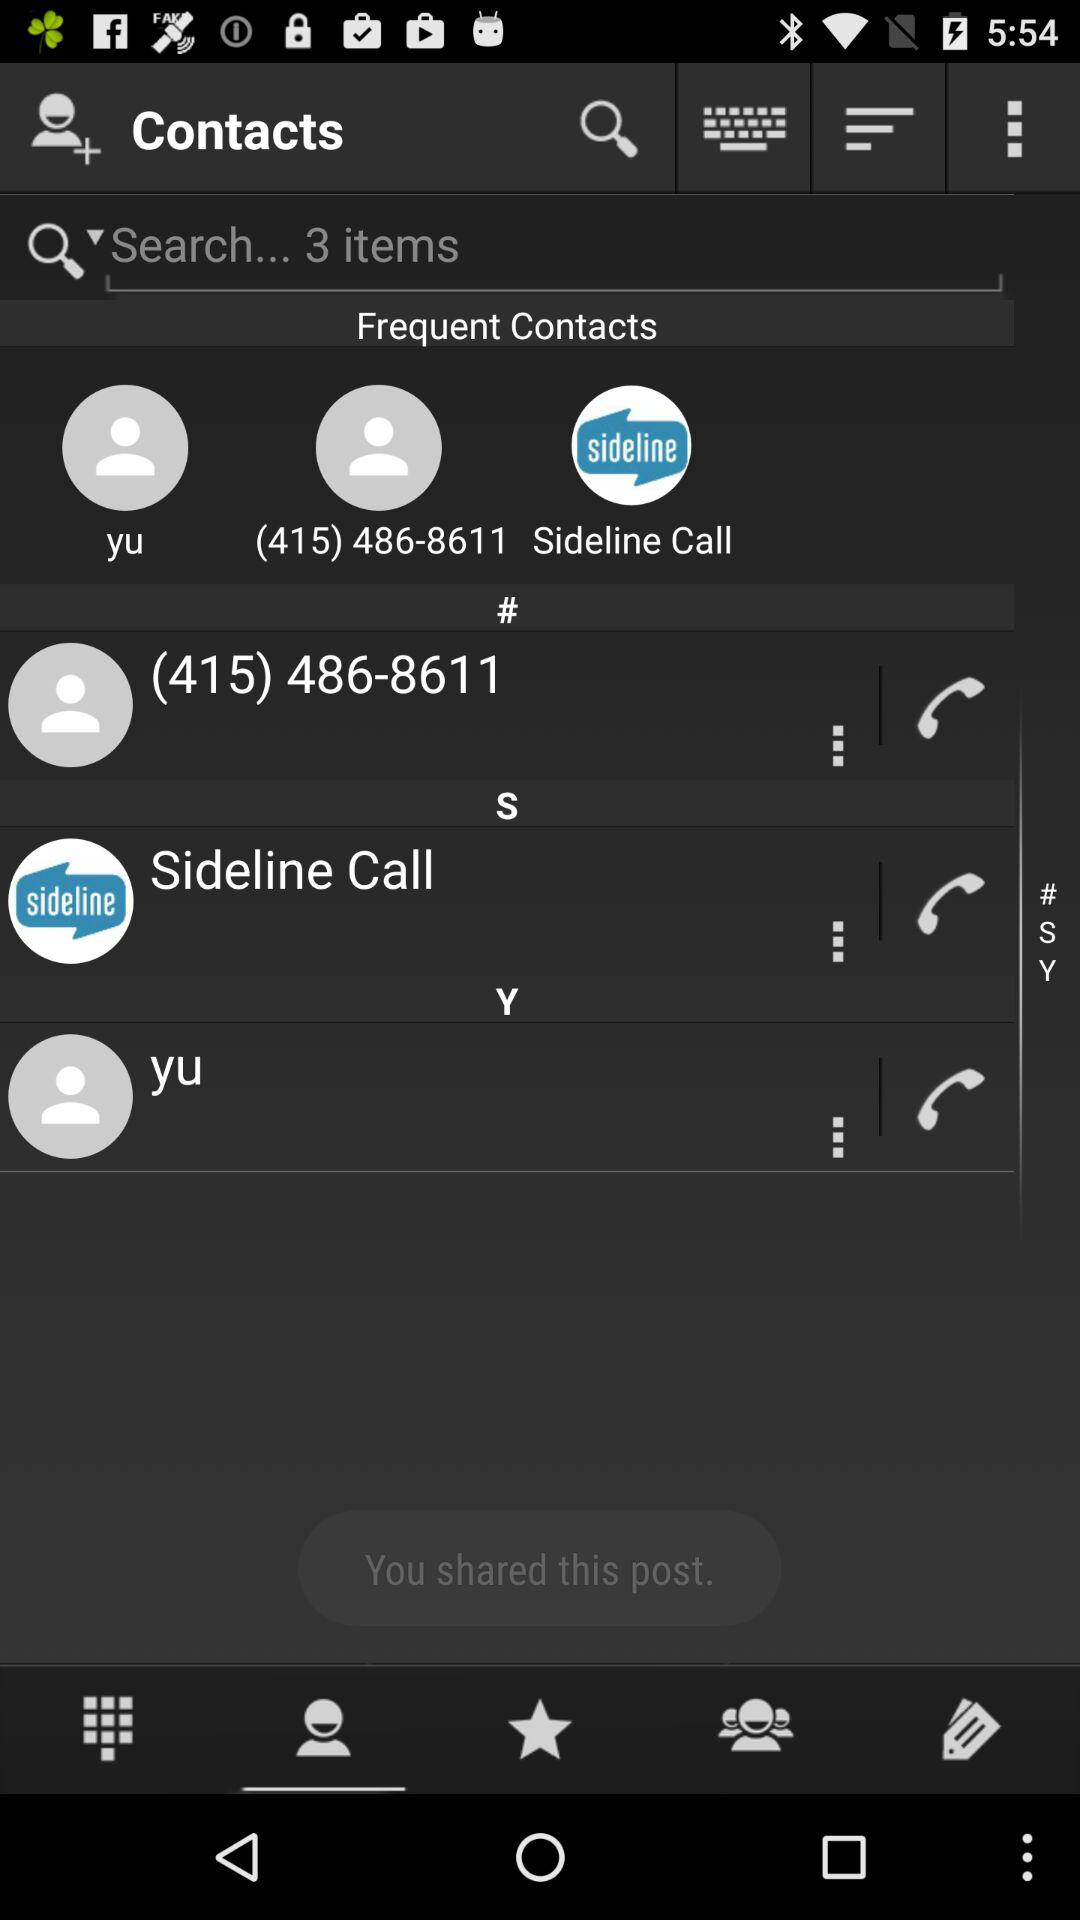Which tab has been selected? The tab that has been selected is "Contacts". 